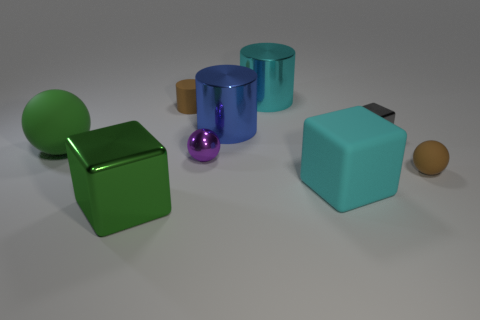What number of things are large shiny things that are behind the big matte ball or tiny matte objects that are on the right side of the gray thing?
Give a very brief answer. 3. What is the color of the large ball?
Your response must be concise. Green. Is the number of blue objects in front of the large cyan matte cube less than the number of small gray rubber objects?
Provide a succinct answer. No. Is there anything else that is the same shape as the tiny gray object?
Offer a very short reply. Yes. Is there a tiny gray cube?
Provide a succinct answer. Yes. Is the number of big cyan blocks less than the number of tiny brown things?
Provide a short and direct response. Yes. How many tiny brown objects have the same material as the large blue cylinder?
Ensure brevity in your answer.  0. What is the color of the other tiny thing that is the same material as the tiny purple object?
Your answer should be compact. Gray. What is the shape of the cyan metal thing?
Give a very brief answer. Cylinder. What number of objects are the same color as the large metal block?
Make the answer very short. 1. 